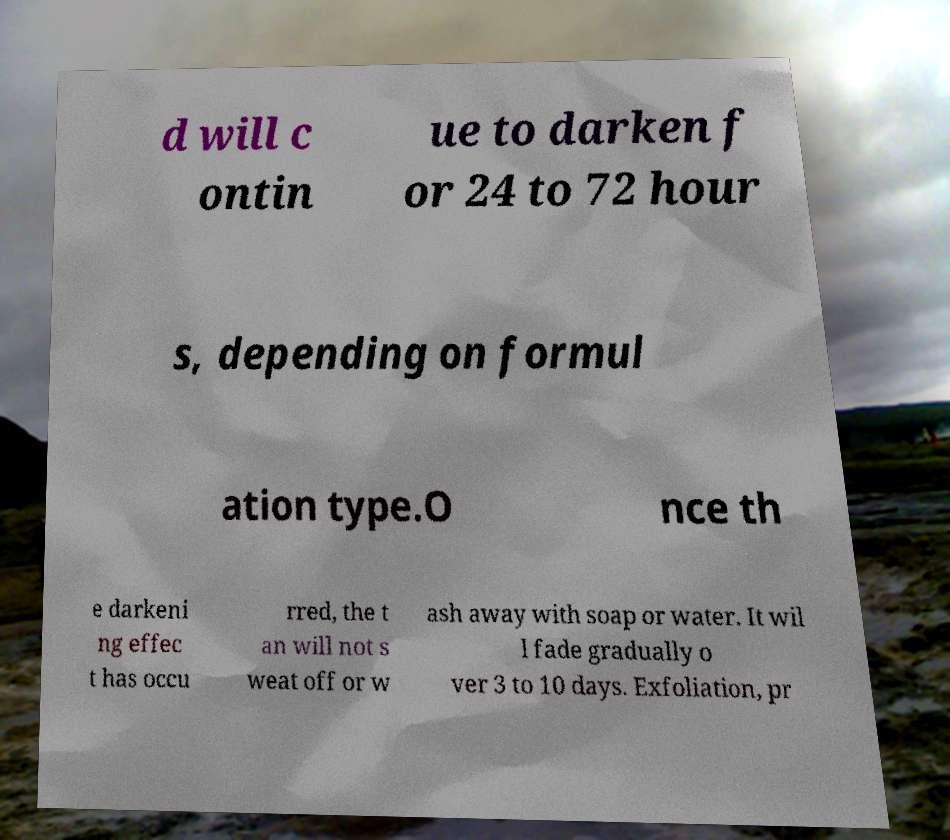There's text embedded in this image that I need extracted. Can you transcribe it verbatim? d will c ontin ue to darken f or 24 to 72 hour s, depending on formul ation type.O nce th e darkeni ng effec t has occu rred, the t an will not s weat off or w ash away with soap or water. It wil l fade gradually o ver 3 to 10 days. Exfoliation, pr 